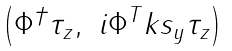Convert formula to latex. <formula><loc_0><loc_0><loc_500><loc_500>\begin{pmatrix} \Phi ^ { \dagger } \tau _ { z } , & i \Phi ^ { T } k s _ { y } \tau _ { z } \end{pmatrix}</formula> 